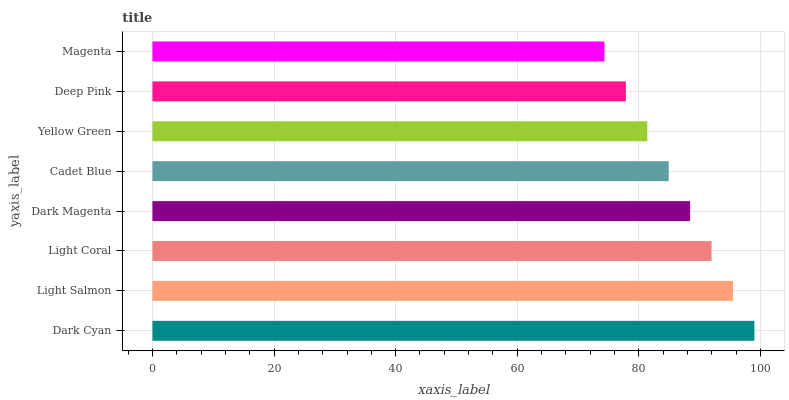Is Magenta the minimum?
Answer yes or no. Yes. Is Dark Cyan the maximum?
Answer yes or no. Yes. Is Light Salmon the minimum?
Answer yes or no. No. Is Light Salmon the maximum?
Answer yes or no. No. Is Dark Cyan greater than Light Salmon?
Answer yes or no. Yes. Is Light Salmon less than Dark Cyan?
Answer yes or no. Yes. Is Light Salmon greater than Dark Cyan?
Answer yes or no. No. Is Dark Cyan less than Light Salmon?
Answer yes or no. No. Is Dark Magenta the high median?
Answer yes or no. Yes. Is Cadet Blue the low median?
Answer yes or no. Yes. Is Light Salmon the high median?
Answer yes or no. No. Is Deep Pink the low median?
Answer yes or no. No. 